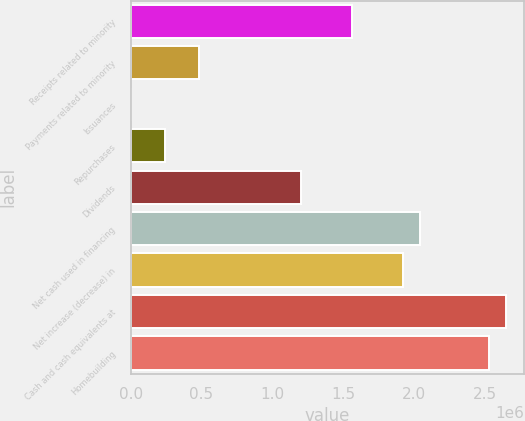<chart> <loc_0><loc_0><loc_500><loc_500><bar_chart><fcel>Receipts related to minority<fcel>Payments related to minority<fcel>Issuances<fcel>Repurchases<fcel>Dividends<fcel>Net cash used in financing<fcel>Net increase (decrease) in<fcel>Cash and cash equivalents at<fcel>Homebuilding<nl><fcel>1.56438e+06<fcel>481503<fcel>224<fcel>240864<fcel>1.20342e+06<fcel>2.04566e+06<fcel>1.92534e+06<fcel>2.64726e+06<fcel>2.52694e+06<nl></chart> 